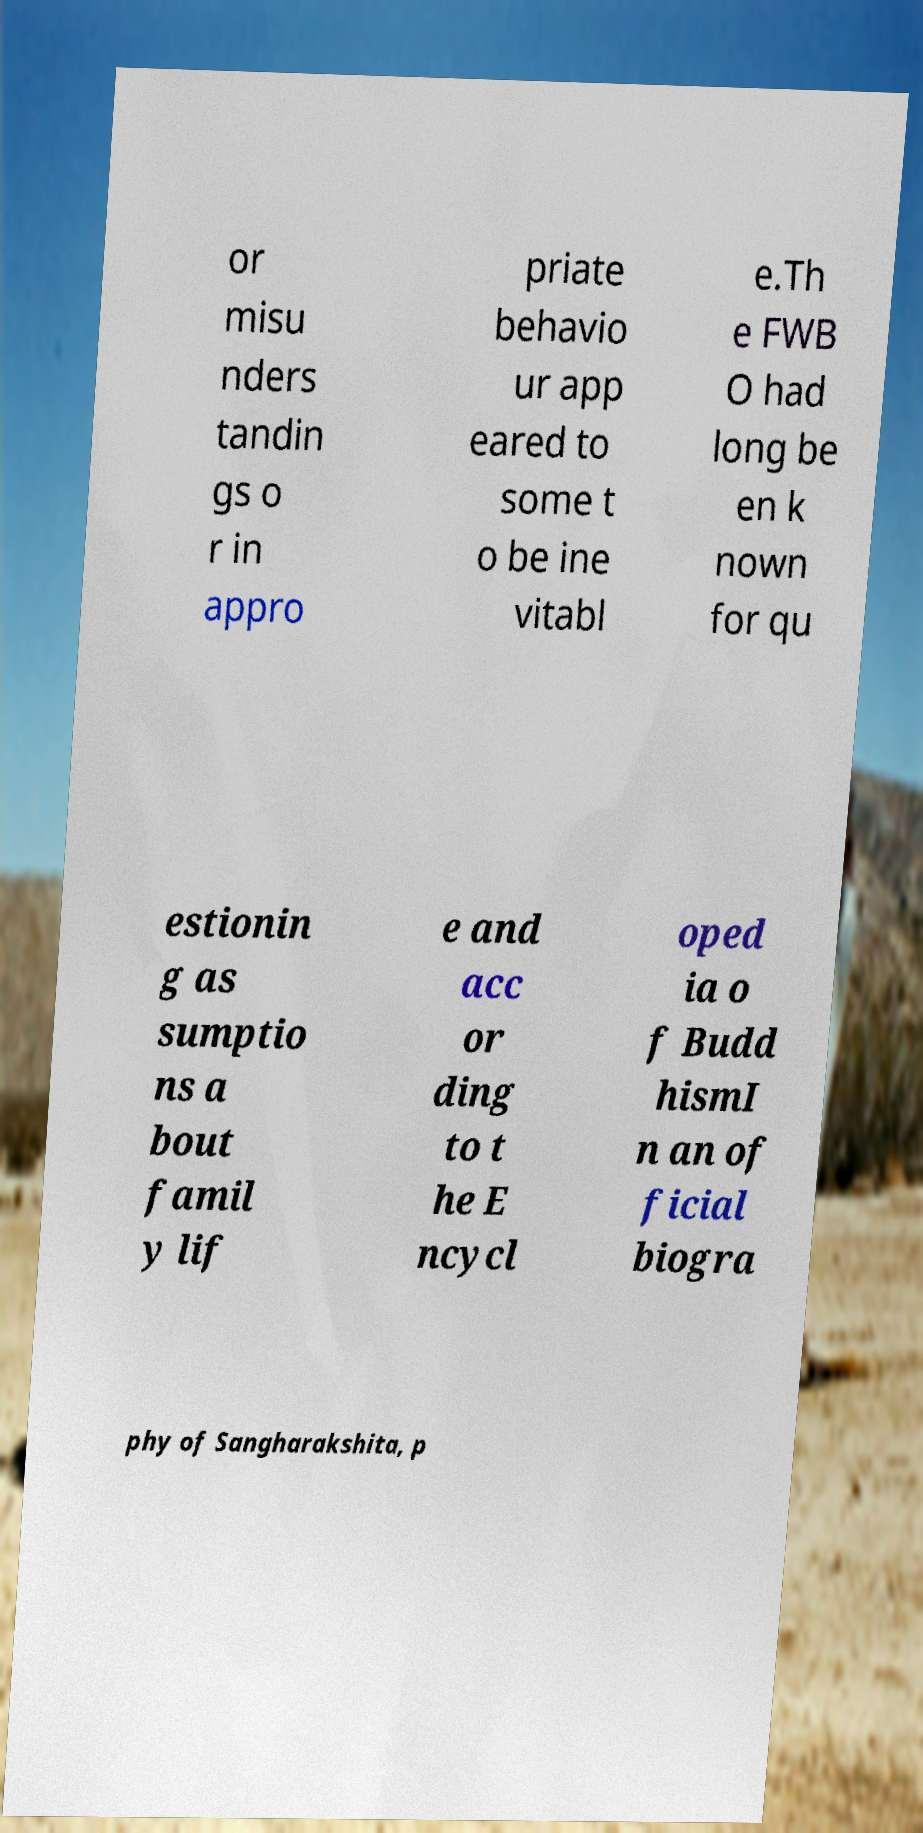Can you accurately transcribe the text from the provided image for me? or misu nders tandin gs o r in appro priate behavio ur app eared to some t o be ine vitabl e.Th e FWB O had long be en k nown for qu estionin g as sumptio ns a bout famil y lif e and acc or ding to t he E ncycl oped ia o f Budd hismI n an of ficial biogra phy of Sangharakshita, p 